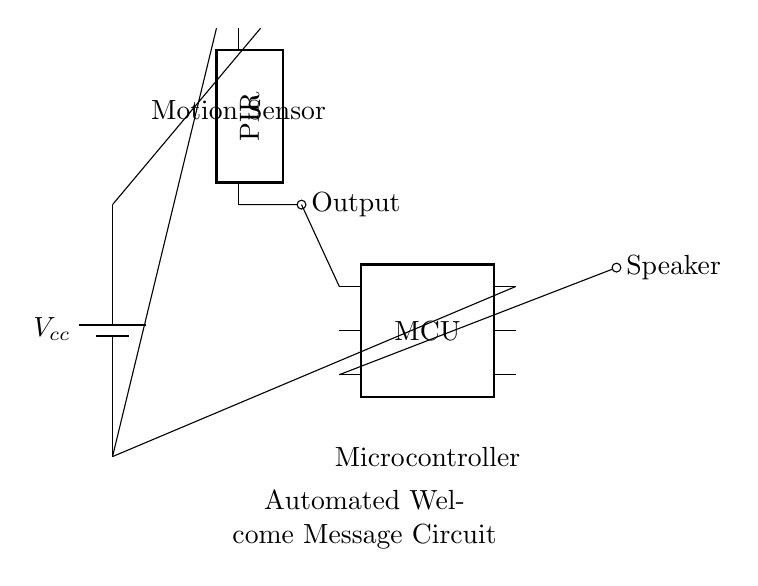What is the input component of the circuit? The input component is the PIR sensor, which detects motion and provides an output signal to the microcontroller.
Answer: PIR sensor How many pins does the microcontroller have? The microcontroller has six pins as indicated in the circuit diagram, each serving a specific function.
Answer: Six What is the output of the PIR sensor? The output of the PIR sensor is indicated and connected to the microcontroller, signifying the detection of motion.
Answer: Output Where is the power supply connected in this circuit? The power supply is connected to the top pin of the PIR sensor and the microcontroller, indicating that both components require power from the battery.
Answer: Top pin What is the purpose of this circuit? This circuit is designed for an automated welcome message, activated by detecting motion through the PIR sensor and controlled by the microcontroller.
Answer: Automated welcome message Which component initiates the welcome message? The microcontroller initiates the welcome message based on the output it receives from the PIR sensor when motion is detected.
Answer: Microcontroller 